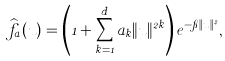Convert formula to latex. <formula><loc_0><loc_0><loc_500><loc_500>\widehat { f } _ { a } ( u ) = \left ( 1 + \sum _ { k = 1 } ^ { d } a _ { k } \| u \| ^ { 2 k } \right ) e ^ { - \pi \| u \| ^ { 2 } } ,</formula> 